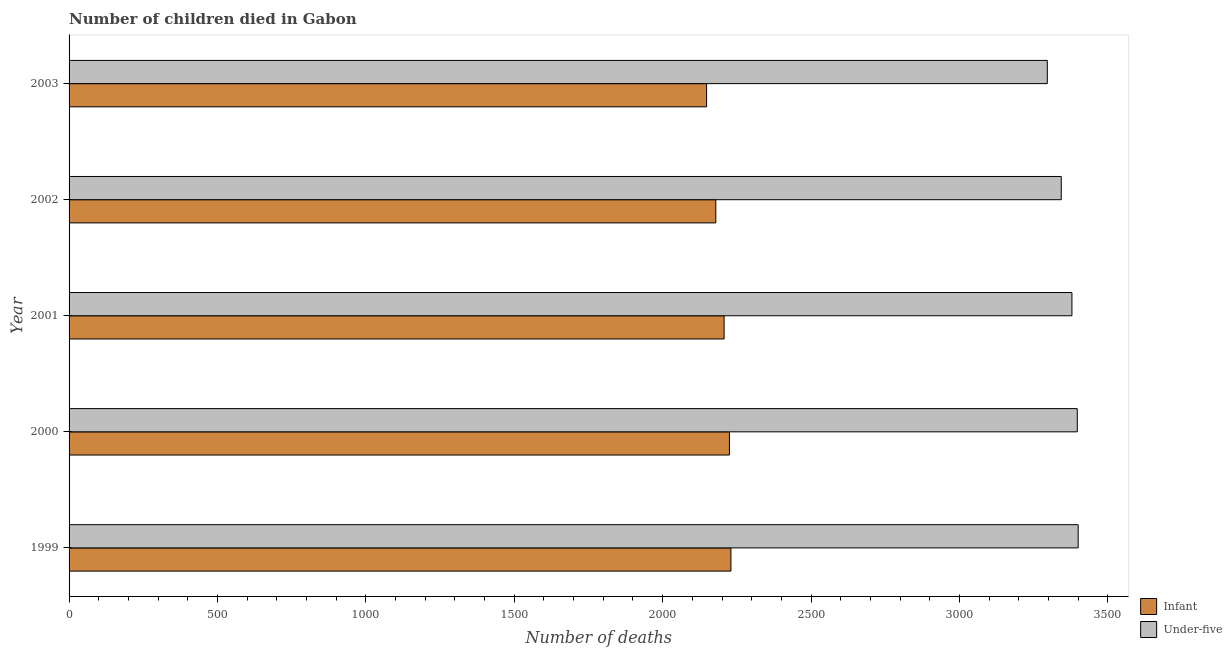How many different coloured bars are there?
Provide a short and direct response. 2. How many groups of bars are there?
Your response must be concise. 5. Are the number of bars per tick equal to the number of legend labels?
Give a very brief answer. Yes. How many bars are there on the 4th tick from the top?
Offer a terse response. 2. How many bars are there on the 5th tick from the bottom?
Offer a very short reply. 2. What is the label of the 1st group of bars from the top?
Offer a very short reply. 2003. In how many cases, is the number of bars for a given year not equal to the number of legend labels?
Provide a succinct answer. 0. What is the number of under-five deaths in 2001?
Provide a short and direct response. 3379. Across all years, what is the maximum number of under-five deaths?
Keep it short and to the point. 3400. Across all years, what is the minimum number of under-five deaths?
Make the answer very short. 3296. In which year was the number of infant deaths maximum?
Your response must be concise. 1999. What is the total number of under-five deaths in the graph?
Your answer should be very brief. 1.68e+04. What is the difference between the number of infant deaths in 2001 and that in 2003?
Offer a terse response. 59. What is the difference between the number of under-five deaths in 1999 and the number of infant deaths in 2003?
Your response must be concise. 1252. What is the average number of infant deaths per year?
Ensure brevity in your answer.  2197.8. In the year 2003, what is the difference between the number of under-five deaths and number of infant deaths?
Provide a succinct answer. 1148. In how many years, is the number of under-five deaths greater than 1900 ?
Your response must be concise. 5. Is the number of infant deaths in 1999 less than that in 2001?
Your answer should be very brief. No. What is the difference between the highest and the lowest number of infant deaths?
Offer a terse response. 82. What does the 2nd bar from the top in 2002 represents?
Offer a terse response. Infant. What does the 2nd bar from the bottom in 2003 represents?
Ensure brevity in your answer.  Under-five. How many years are there in the graph?
Keep it short and to the point. 5. What is the difference between two consecutive major ticks on the X-axis?
Offer a terse response. 500. How many legend labels are there?
Your answer should be compact. 2. How are the legend labels stacked?
Provide a succinct answer. Vertical. What is the title of the graph?
Your answer should be very brief. Number of children died in Gabon. What is the label or title of the X-axis?
Your answer should be very brief. Number of deaths. What is the label or title of the Y-axis?
Give a very brief answer. Year. What is the Number of deaths of Infant in 1999?
Make the answer very short. 2230. What is the Number of deaths in Under-five in 1999?
Your answer should be very brief. 3400. What is the Number of deaths of Infant in 2000?
Your response must be concise. 2225. What is the Number of deaths in Under-five in 2000?
Offer a very short reply. 3397. What is the Number of deaths of Infant in 2001?
Make the answer very short. 2207. What is the Number of deaths of Under-five in 2001?
Make the answer very short. 3379. What is the Number of deaths in Infant in 2002?
Provide a short and direct response. 2179. What is the Number of deaths in Under-five in 2002?
Give a very brief answer. 3343. What is the Number of deaths in Infant in 2003?
Your answer should be compact. 2148. What is the Number of deaths in Under-five in 2003?
Provide a succinct answer. 3296. Across all years, what is the maximum Number of deaths in Infant?
Provide a short and direct response. 2230. Across all years, what is the maximum Number of deaths in Under-five?
Provide a succinct answer. 3400. Across all years, what is the minimum Number of deaths of Infant?
Make the answer very short. 2148. Across all years, what is the minimum Number of deaths in Under-five?
Make the answer very short. 3296. What is the total Number of deaths in Infant in the graph?
Give a very brief answer. 1.10e+04. What is the total Number of deaths of Under-five in the graph?
Your answer should be very brief. 1.68e+04. What is the difference between the Number of deaths in Infant in 1999 and that in 2000?
Keep it short and to the point. 5. What is the difference between the Number of deaths in Under-five in 1999 and that in 2001?
Make the answer very short. 21. What is the difference between the Number of deaths of Under-five in 1999 and that in 2002?
Provide a short and direct response. 57. What is the difference between the Number of deaths of Under-five in 1999 and that in 2003?
Your answer should be compact. 104. What is the difference between the Number of deaths in Under-five in 2000 and that in 2001?
Make the answer very short. 18. What is the difference between the Number of deaths of Infant in 2000 and that in 2003?
Your answer should be very brief. 77. What is the difference between the Number of deaths in Under-five in 2000 and that in 2003?
Ensure brevity in your answer.  101. What is the difference between the Number of deaths of Infant in 2001 and that in 2002?
Ensure brevity in your answer.  28. What is the difference between the Number of deaths in Infant in 2001 and that in 2003?
Your answer should be very brief. 59. What is the difference between the Number of deaths in Under-five in 2001 and that in 2003?
Your answer should be compact. 83. What is the difference between the Number of deaths in Infant in 2002 and that in 2003?
Your response must be concise. 31. What is the difference between the Number of deaths in Under-five in 2002 and that in 2003?
Offer a terse response. 47. What is the difference between the Number of deaths in Infant in 1999 and the Number of deaths in Under-five in 2000?
Provide a short and direct response. -1167. What is the difference between the Number of deaths of Infant in 1999 and the Number of deaths of Under-five in 2001?
Offer a very short reply. -1149. What is the difference between the Number of deaths of Infant in 1999 and the Number of deaths of Under-five in 2002?
Ensure brevity in your answer.  -1113. What is the difference between the Number of deaths in Infant in 1999 and the Number of deaths in Under-five in 2003?
Ensure brevity in your answer.  -1066. What is the difference between the Number of deaths of Infant in 2000 and the Number of deaths of Under-five in 2001?
Keep it short and to the point. -1154. What is the difference between the Number of deaths of Infant in 2000 and the Number of deaths of Under-five in 2002?
Make the answer very short. -1118. What is the difference between the Number of deaths in Infant in 2000 and the Number of deaths in Under-five in 2003?
Offer a terse response. -1071. What is the difference between the Number of deaths in Infant in 2001 and the Number of deaths in Under-five in 2002?
Ensure brevity in your answer.  -1136. What is the difference between the Number of deaths of Infant in 2001 and the Number of deaths of Under-five in 2003?
Provide a short and direct response. -1089. What is the difference between the Number of deaths in Infant in 2002 and the Number of deaths in Under-five in 2003?
Make the answer very short. -1117. What is the average Number of deaths of Infant per year?
Make the answer very short. 2197.8. What is the average Number of deaths in Under-five per year?
Your answer should be very brief. 3363. In the year 1999, what is the difference between the Number of deaths in Infant and Number of deaths in Under-five?
Your answer should be very brief. -1170. In the year 2000, what is the difference between the Number of deaths in Infant and Number of deaths in Under-five?
Make the answer very short. -1172. In the year 2001, what is the difference between the Number of deaths of Infant and Number of deaths of Under-five?
Ensure brevity in your answer.  -1172. In the year 2002, what is the difference between the Number of deaths of Infant and Number of deaths of Under-five?
Your answer should be very brief. -1164. In the year 2003, what is the difference between the Number of deaths in Infant and Number of deaths in Under-five?
Your response must be concise. -1148. What is the ratio of the Number of deaths in Infant in 1999 to that in 2000?
Offer a very short reply. 1. What is the ratio of the Number of deaths in Infant in 1999 to that in 2001?
Provide a succinct answer. 1.01. What is the ratio of the Number of deaths in Under-five in 1999 to that in 2001?
Keep it short and to the point. 1.01. What is the ratio of the Number of deaths of Infant in 1999 to that in 2002?
Provide a succinct answer. 1.02. What is the ratio of the Number of deaths of Under-five in 1999 to that in 2002?
Provide a short and direct response. 1.02. What is the ratio of the Number of deaths of Infant in 1999 to that in 2003?
Your response must be concise. 1.04. What is the ratio of the Number of deaths in Under-five in 1999 to that in 2003?
Offer a terse response. 1.03. What is the ratio of the Number of deaths in Infant in 2000 to that in 2001?
Make the answer very short. 1.01. What is the ratio of the Number of deaths of Under-five in 2000 to that in 2001?
Give a very brief answer. 1.01. What is the ratio of the Number of deaths of Infant in 2000 to that in 2002?
Your answer should be very brief. 1.02. What is the ratio of the Number of deaths of Under-five in 2000 to that in 2002?
Keep it short and to the point. 1.02. What is the ratio of the Number of deaths in Infant in 2000 to that in 2003?
Provide a short and direct response. 1.04. What is the ratio of the Number of deaths of Under-five in 2000 to that in 2003?
Keep it short and to the point. 1.03. What is the ratio of the Number of deaths of Infant in 2001 to that in 2002?
Make the answer very short. 1.01. What is the ratio of the Number of deaths of Under-five in 2001 to that in 2002?
Your response must be concise. 1.01. What is the ratio of the Number of deaths in Infant in 2001 to that in 2003?
Offer a terse response. 1.03. What is the ratio of the Number of deaths of Under-five in 2001 to that in 2003?
Give a very brief answer. 1.03. What is the ratio of the Number of deaths in Infant in 2002 to that in 2003?
Your response must be concise. 1.01. What is the ratio of the Number of deaths in Under-five in 2002 to that in 2003?
Provide a succinct answer. 1.01. What is the difference between the highest and the second highest Number of deaths in Infant?
Make the answer very short. 5. What is the difference between the highest and the lowest Number of deaths of Infant?
Your response must be concise. 82. What is the difference between the highest and the lowest Number of deaths of Under-five?
Your answer should be compact. 104. 